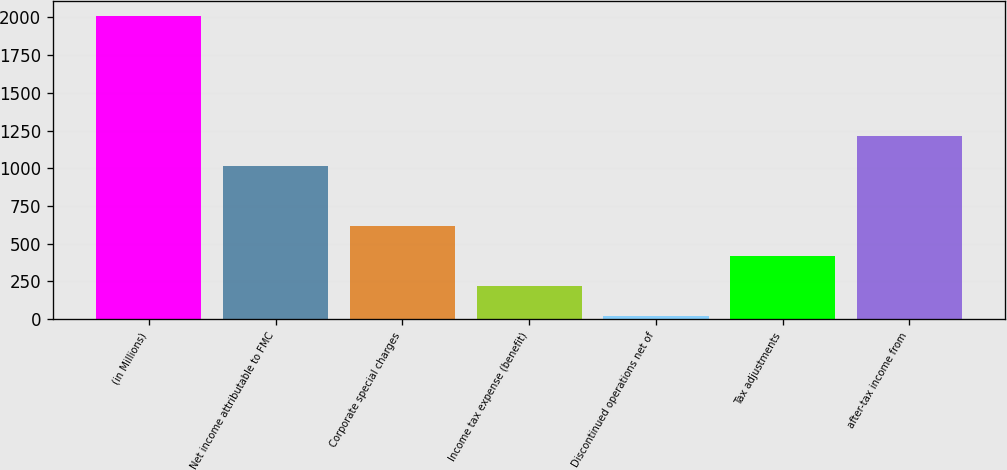Convert chart to OTSL. <chart><loc_0><loc_0><loc_500><loc_500><bar_chart><fcel>(in Millions)<fcel>Net income attributable to FMC<fcel>Corporate special charges<fcel>Income tax expense (benefit)<fcel>Discontinued operations net of<fcel>Tax adjustments<fcel>after-tax income from<nl><fcel>2009<fcel>1013.6<fcel>615.44<fcel>217.28<fcel>18.2<fcel>416.36<fcel>1212.68<nl></chart> 